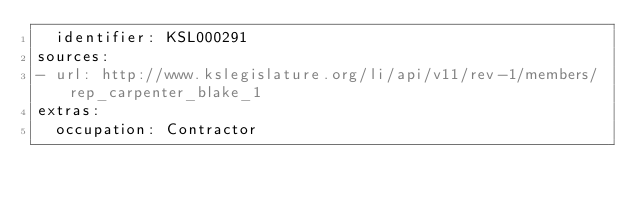Convert code to text. <code><loc_0><loc_0><loc_500><loc_500><_YAML_>  identifier: KSL000291
sources:
- url: http://www.kslegislature.org/li/api/v11/rev-1/members/rep_carpenter_blake_1
extras:
  occupation: Contractor
</code> 